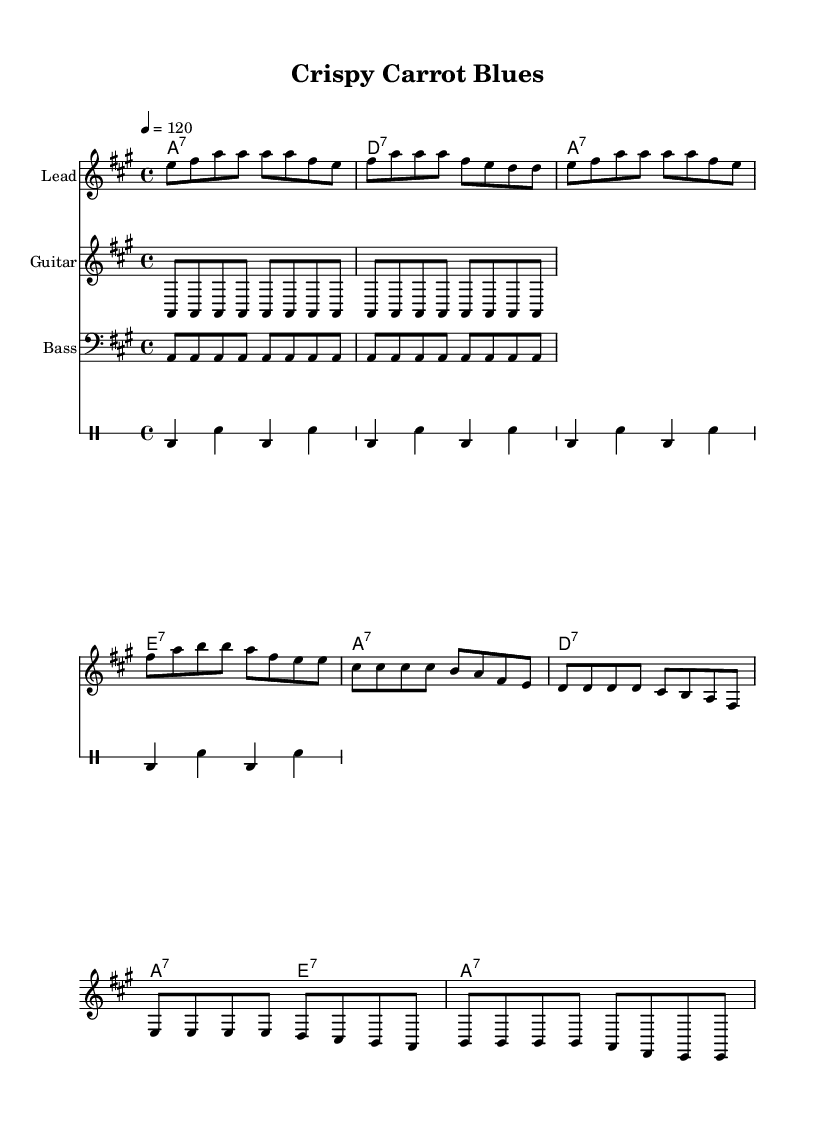What is the key signature of this music? The key signature indicates that this piece is in A major, which has three sharps (F#, C#, and G#). This is confirmed by the presence of these sharps in the key signature at the beginning of the staff.
Answer: A major What is the time signature of this music? The time signature is located at the beginning of the staff and shows a 4/4 meter. This means there are four beats in each measure and the quarter note gets one beat.
Answer: 4/4 What is the tempo marking of this music? The tempo marking is indicated by "4 = 120" at the beginning, which specifies that the quarter note (4) should be played at a speed of 120 beats per minute.
Answer: 120 How many measures are in the verse? By counting the measures in the verse section defined in the code, there are a total of four measures. This can be observed by recognizing the patterns and how they are grouped in the sheet music.
Answer: Four What instrument is the lead part written for? The lead part is noted in the score as "Lead," which suggests it is meant for a solo instrument capable of playing melodic lines, typically a guitar or keyboard in an Electric Blues context.
Answer: Lead What is the lyrical theme of the chorus? The lyrics describe the benefits of eating fresh fruits and vegetables, celebrating their nutritional goodness and highlighting the catchy phrase "crispy carrot blues." This is a thematic element common in the upbeat Electric Blues genre.
Answer: Fresh fruits and vegetables 